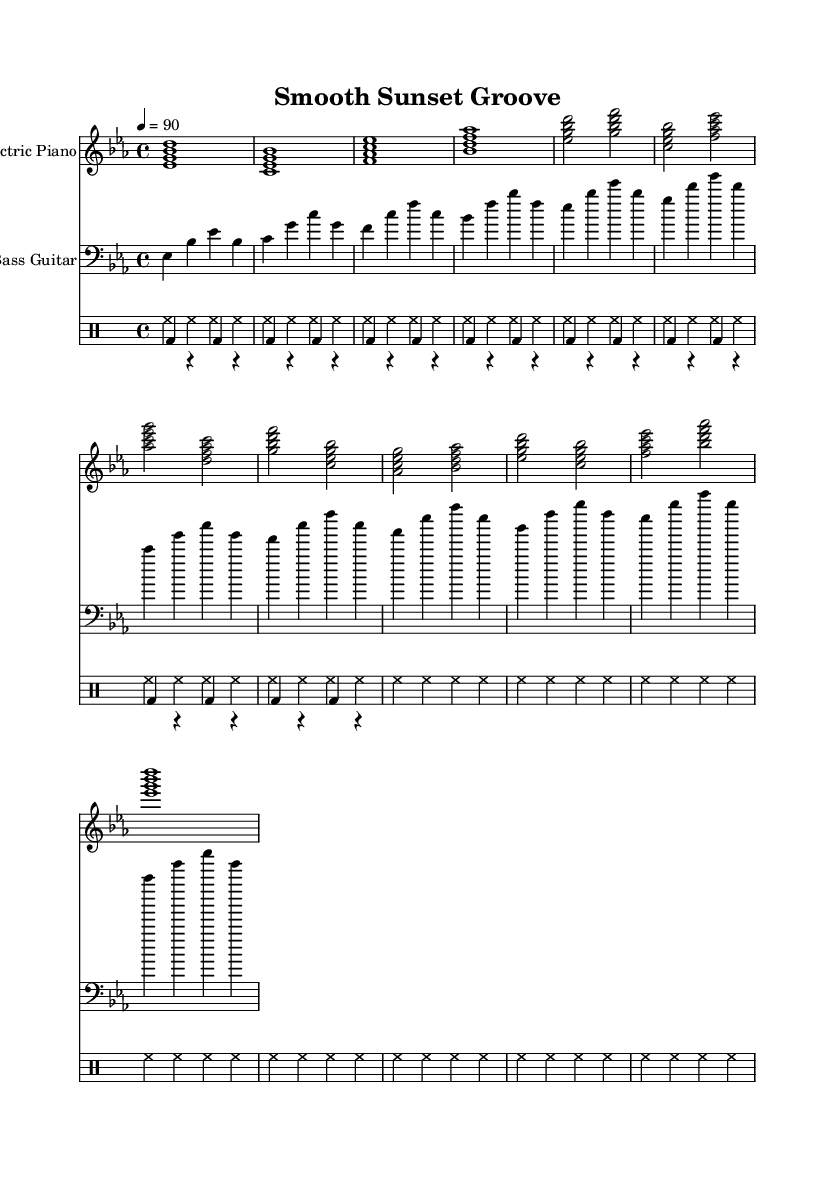What is the key signature of this music? The key signature indicated in the sheet music is E flat major, which has three flats (B flat, E flat, and A flat). We can identify this by looking at the key signature found at the beginning of the staff, next to the clef.
Answer: E flat major What is the time signature of the music? The time signature shown at the beginning of the score is 4/4. This means there are four beats in each measure, and the quarter note receives one beat. This information is located to the right of the key signature.
Answer: 4/4 What is the tempo marking of the piece? The tempo marking is 90 beats per minute, indicated by the number '4 = 90' at the start of the score. This means that the quarter note is played at a rate of 90 beats per minute.
Answer: 90 How many measures are in the verse section? The verse section contains a total of four measures. By counting the measures identified in the score under the verse section, we see that they are clearly defined by the music notation and structured lines.
Answer: Four What type of instrument is used for the main melody? The primary instrument for the melody in this piece is the Electric Piano, which is specified at the beginning of the corresponding staff. This information is also commonly found in the instrument name settings.
Answer: Electric Piano What rhythmic pattern is used for the bass guitar? The bass guitar employs a rhythmic pattern of quarter notes that alternate between root notes, fifths, and octaves. By examining the written notes for the bass part, we can see this consistent pattern repeated throughout.
Answer: Root - 5th - Octave - 5th How does the bass guitar contribute to the overall feel of the music? The bass guitar contributes to a laid-back feel through its subtle groove and simple rhythmic pattern that complements the mellow electric piano. By analyzing the bass lines and how they relate to the overall structure, one can appreciate how they provide a smooth foundation for the funk genre.
Answer: Smooth foundation 